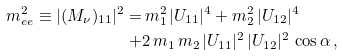Convert formula to latex. <formula><loc_0><loc_0><loc_500><loc_500>m _ { e e } ^ { 2 } \equiv | ( M _ { \nu } ) _ { 1 1 } | ^ { 2 } = & \, m _ { 1 } ^ { 2 } \, | U _ { 1 1 } | ^ { 4 } + m _ { 2 } ^ { 2 } \, | U _ { 1 2 } | ^ { 4 } \\ + & 2 \, m _ { 1 } \, m _ { 2 } \, | U _ { 1 1 } | ^ { 2 } \, | U _ { 1 2 } | ^ { 2 } \, \cos \alpha \, ,</formula> 